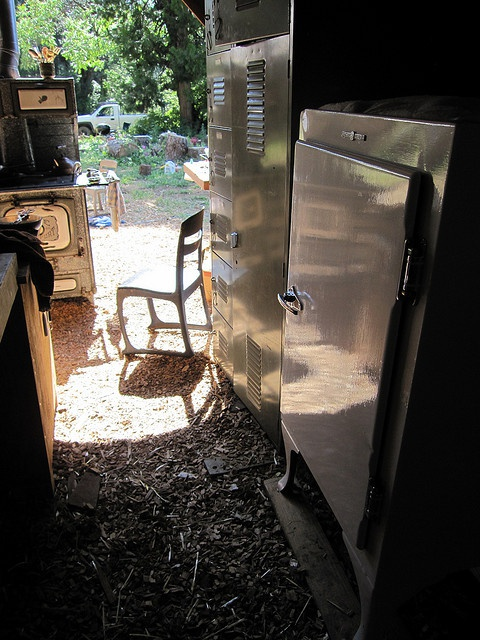Describe the objects in this image and their specific colors. I can see refrigerator in black, gray, and tan tones, chair in black, white, and gray tones, truck in black, lightgray, lightblue, gray, and darkgray tones, dining table in black, white, tan, and darkgray tones, and dining table in black, white, tan, brown, and darkgray tones in this image. 